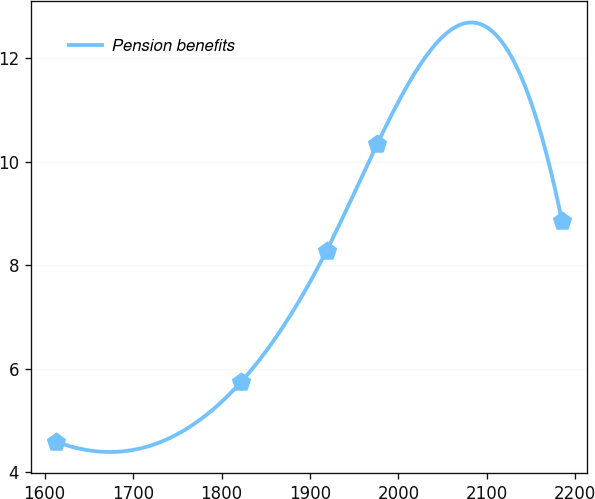Convert chart to OTSL. <chart><loc_0><loc_0><loc_500><loc_500><line_chart><ecel><fcel>Pension benefits<nl><fcel>1612.84<fcel>4.59<nl><fcel>1821.87<fcel>5.74<nl><fcel>1918.69<fcel>8.28<nl><fcel>1975.9<fcel>10.34<nl><fcel>2184.91<fcel>8.85<nl></chart> 